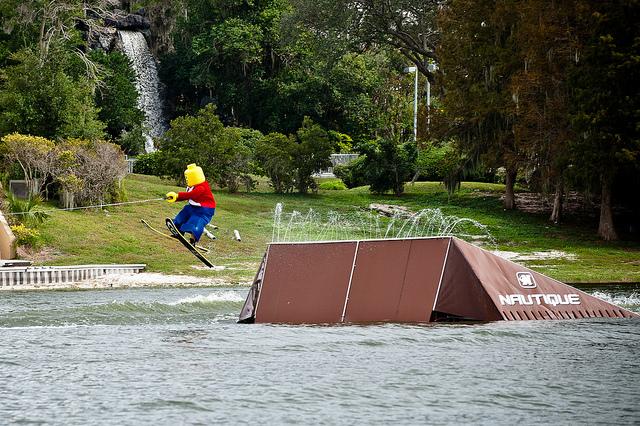Is this a forest?
Give a very brief answer. No. Where is this?
Answer briefly. Lake. How deep is the water in this photograph?
Keep it brief. 20 feet. What character is in the picture?
Answer briefly. Lego. 